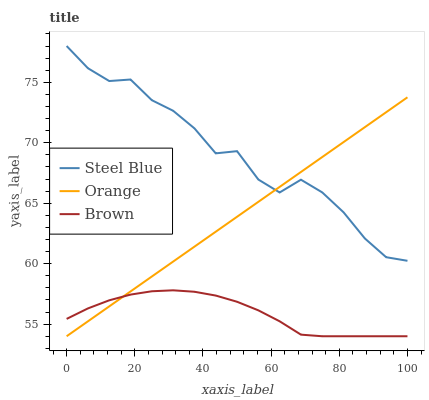Does Steel Blue have the minimum area under the curve?
Answer yes or no. No. Does Brown have the maximum area under the curve?
Answer yes or no. No. Is Brown the smoothest?
Answer yes or no. No. Is Brown the roughest?
Answer yes or no. No. Does Steel Blue have the lowest value?
Answer yes or no. No. Does Brown have the highest value?
Answer yes or no. No. Is Brown less than Steel Blue?
Answer yes or no. Yes. Is Steel Blue greater than Brown?
Answer yes or no. Yes. Does Brown intersect Steel Blue?
Answer yes or no. No. 